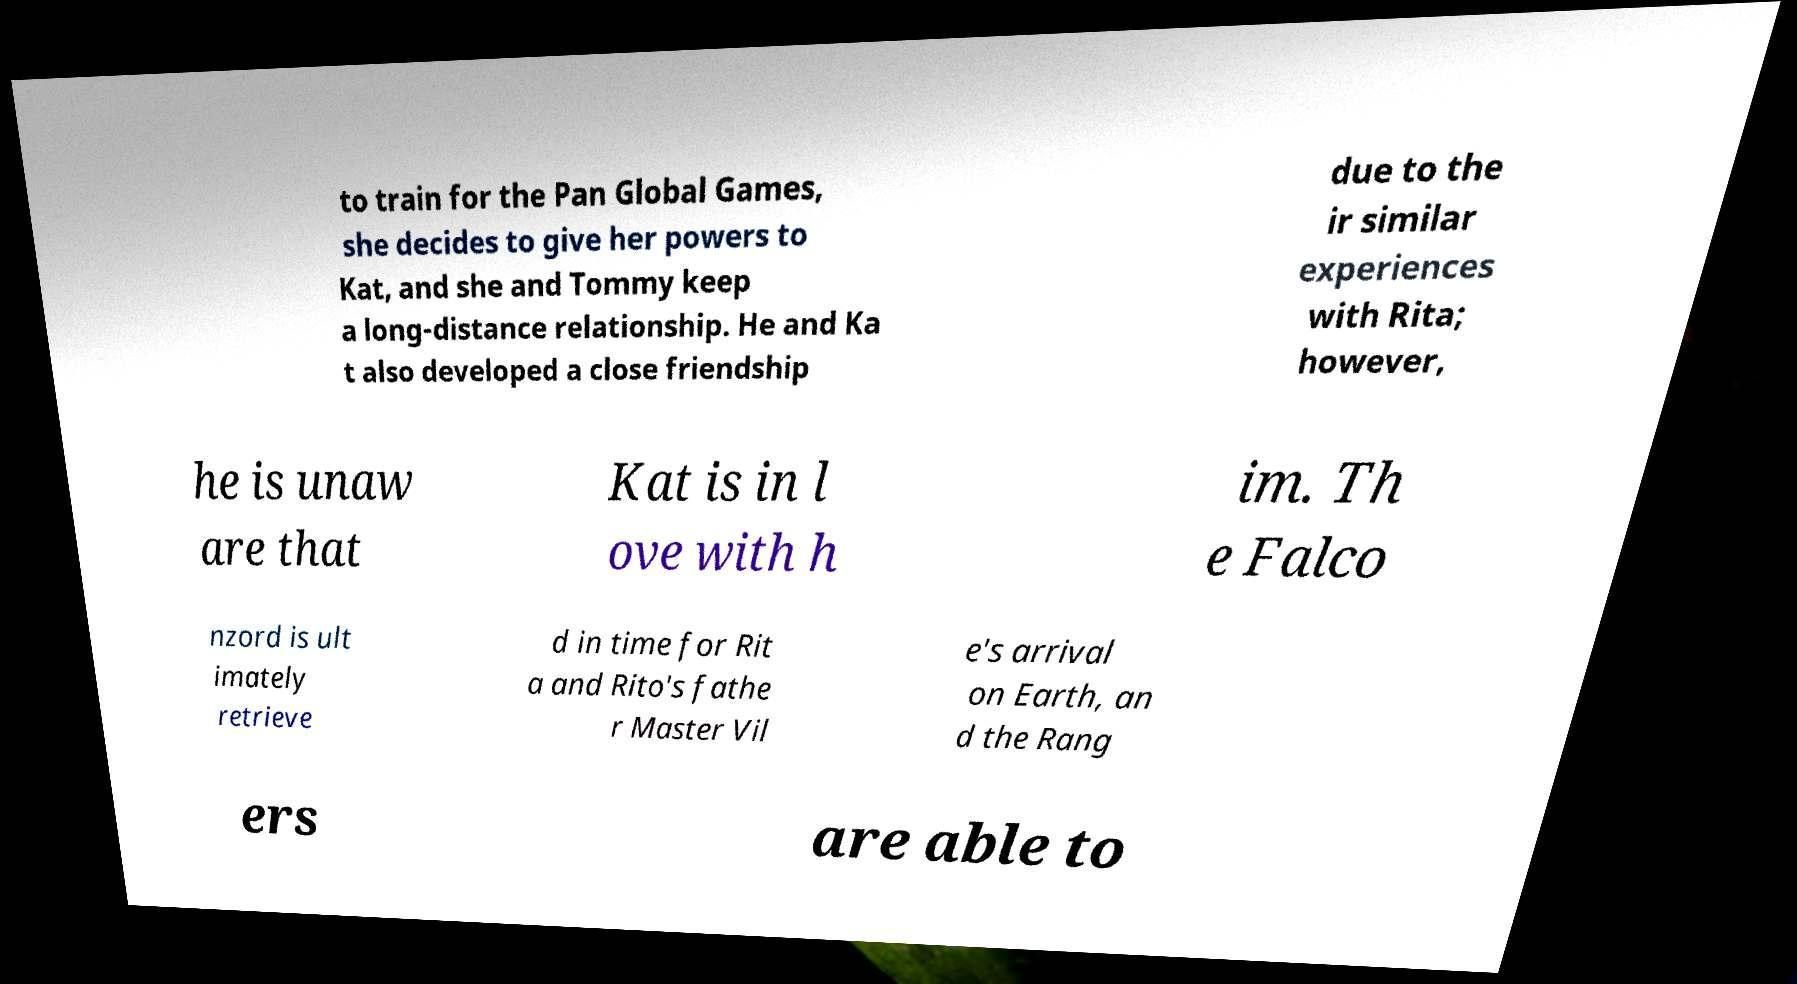Could you extract and type out the text from this image? to train for the Pan Global Games, she decides to give her powers to Kat, and she and Tommy keep a long-distance relationship. He and Ka t also developed a close friendship due to the ir similar experiences with Rita; however, he is unaw are that Kat is in l ove with h im. Th e Falco nzord is ult imately retrieve d in time for Rit a and Rito's fathe r Master Vil e's arrival on Earth, an d the Rang ers are able to 